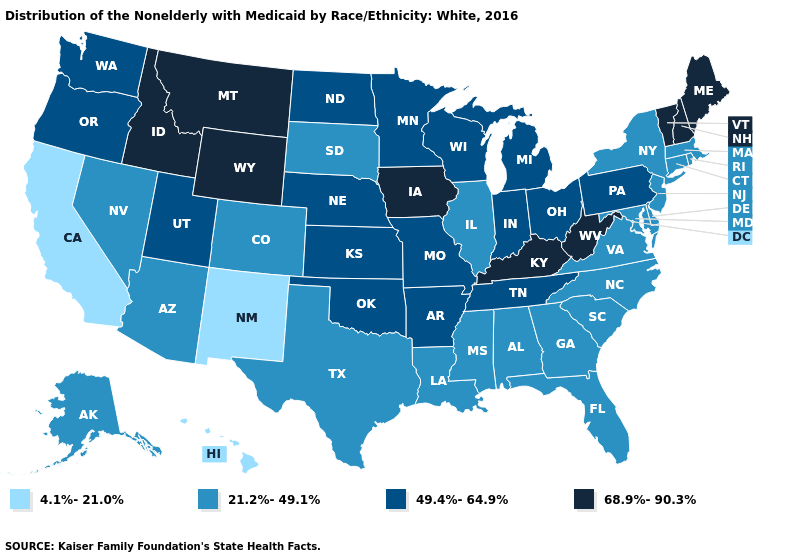Does Delaware have a higher value than Hawaii?
Quick response, please. Yes. Which states have the highest value in the USA?
Short answer required. Idaho, Iowa, Kentucky, Maine, Montana, New Hampshire, Vermont, West Virginia, Wyoming. What is the highest value in states that border Florida?
Write a very short answer. 21.2%-49.1%. Among the states that border Maryland , does Pennsylvania have the lowest value?
Quick response, please. No. Which states hav the highest value in the Northeast?
Quick response, please. Maine, New Hampshire, Vermont. Among the states that border Montana , which have the highest value?
Be succinct. Idaho, Wyoming. What is the value of Mississippi?
Concise answer only. 21.2%-49.1%. What is the value of Georgia?
Keep it brief. 21.2%-49.1%. What is the value of Indiana?
Short answer required. 49.4%-64.9%. Among the states that border Indiana , which have the highest value?
Write a very short answer. Kentucky. Name the states that have a value in the range 21.2%-49.1%?
Give a very brief answer. Alabama, Alaska, Arizona, Colorado, Connecticut, Delaware, Florida, Georgia, Illinois, Louisiana, Maryland, Massachusetts, Mississippi, Nevada, New Jersey, New York, North Carolina, Rhode Island, South Carolina, South Dakota, Texas, Virginia. Among the states that border Arizona , which have the lowest value?
Answer briefly. California, New Mexico. Does New Hampshire have the highest value in the Northeast?
Answer briefly. Yes. Name the states that have a value in the range 49.4%-64.9%?
Give a very brief answer. Arkansas, Indiana, Kansas, Michigan, Minnesota, Missouri, Nebraska, North Dakota, Ohio, Oklahoma, Oregon, Pennsylvania, Tennessee, Utah, Washington, Wisconsin. What is the value of North Dakota?
Give a very brief answer. 49.4%-64.9%. 